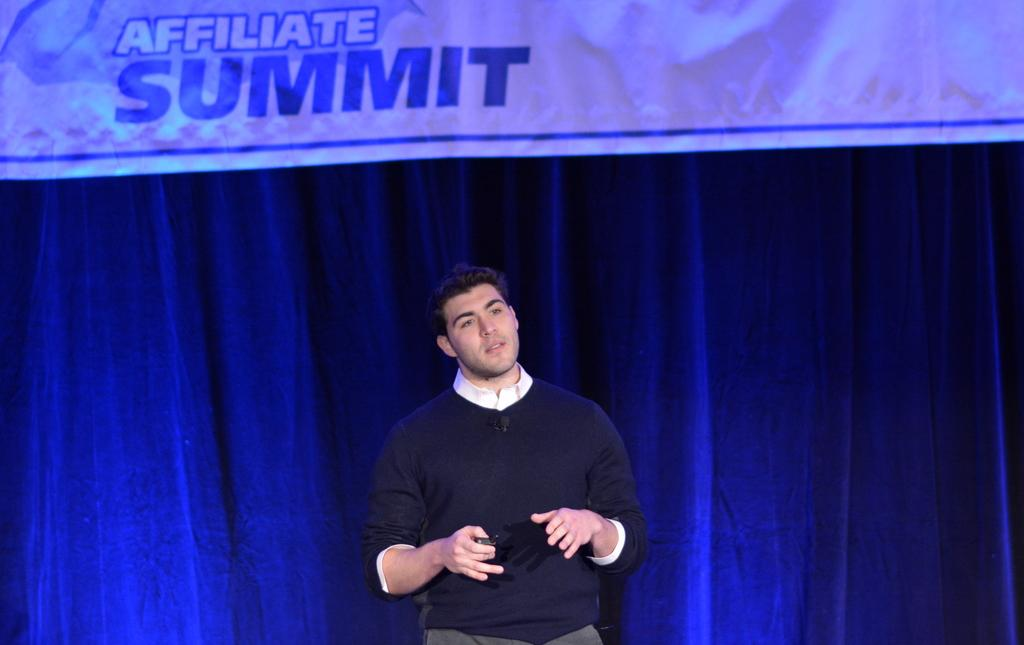What is the man in the image doing? The man is standing in the image. What is the man holding in his hand? The man is holding an object in his hand. What can be seen in the background of the image? There is a curtain and a banner with some text in the background of the image. What type of pencil can be seen on the man's vacation in the image? There is no pencil or reference to a vacation present in the image. 